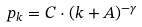Convert formula to latex. <formula><loc_0><loc_0><loc_500><loc_500>p _ { k } = C \cdot ( k + A ) ^ { - \gamma }</formula> 